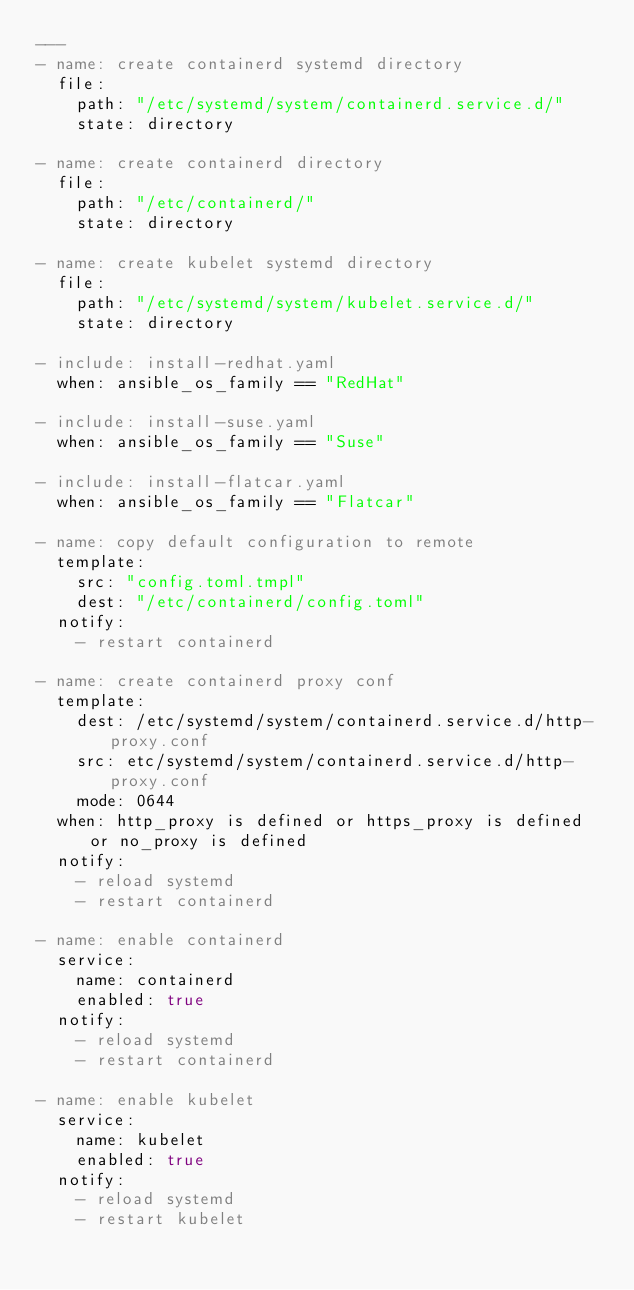<code> <loc_0><loc_0><loc_500><loc_500><_YAML_>---
- name: create containerd systemd directory
  file:
    path: "/etc/systemd/system/containerd.service.d/"
    state: directory

- name: create containerd directory
  file:
    path: "/etc/containerd/"
    state: directory

- name: create kubelet systemd directory
  file:
    path: "/etc/systemd/system/kubelet.service.d/"
    state: directory

- include: install-redhat.yaml
  when: ansible_os_family == "RedHat"

- include: install-suse.yaml
  when: ansible_os_family == "Suse"

- include: install-flatcar.yaml
  when: ansible_os_family == "Flatcar"

- name: copy default configuration to remote
  template:
    src: "config.toml.tmpl"
    dest: "/etc/containerd/config.toml"
  notify:
    - restart containerd

- name: create containerd proxy conf
  template:
    dest: /etc/systemd/system/containerd.service.d/http-proxy.conf
    src: etc/systemd/system/containerd.service.d/http-proxy.conf
    mode: 0644
  when: http_proxy is defined or https_proxy is defined or no_proxy is defined
  notify:
    - reload systemd
    - restart containerd

- name: enable containerd
  service:
    name: containerd
    enabled: true
  notify:
    - reload systemd
    - restart containerd

- name: enable kubelet
  service:
    name: kubelet
    enabled: true
  notify:
    - reload systemd
    - restart kubelet
</code> 